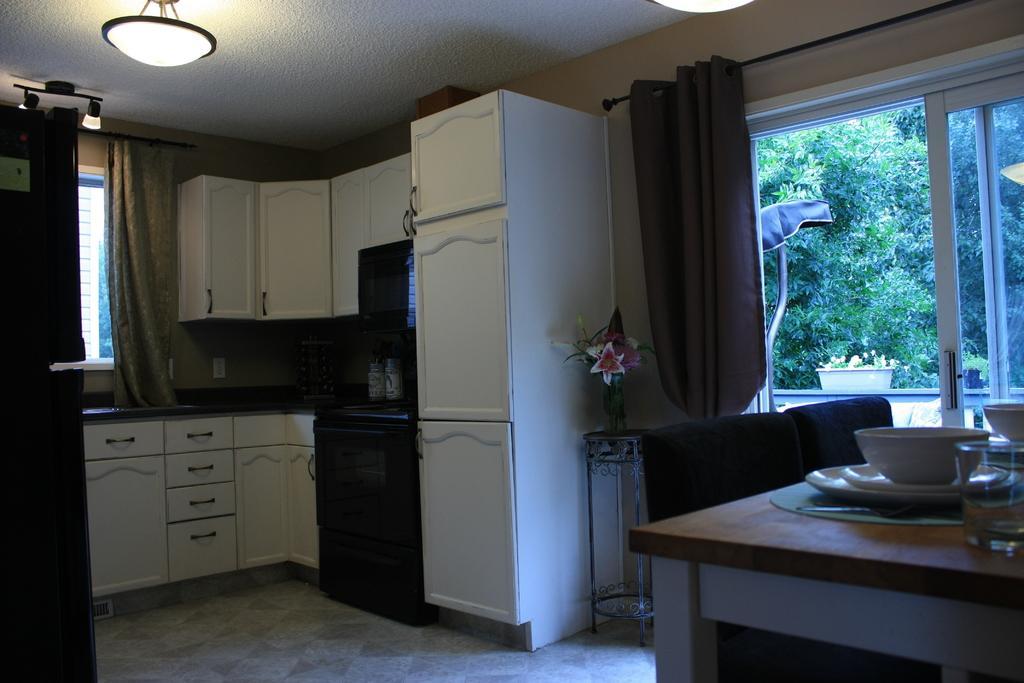How would you summarize this image in a sentence or two? This is an inside picture of the room, there are chairs and a table, on the table, we can see some plates, bowls and a glass, there are some cupboards, curtains, lights and a flower vase on the stand, also we can see some trees and a potted plant on the wall. 